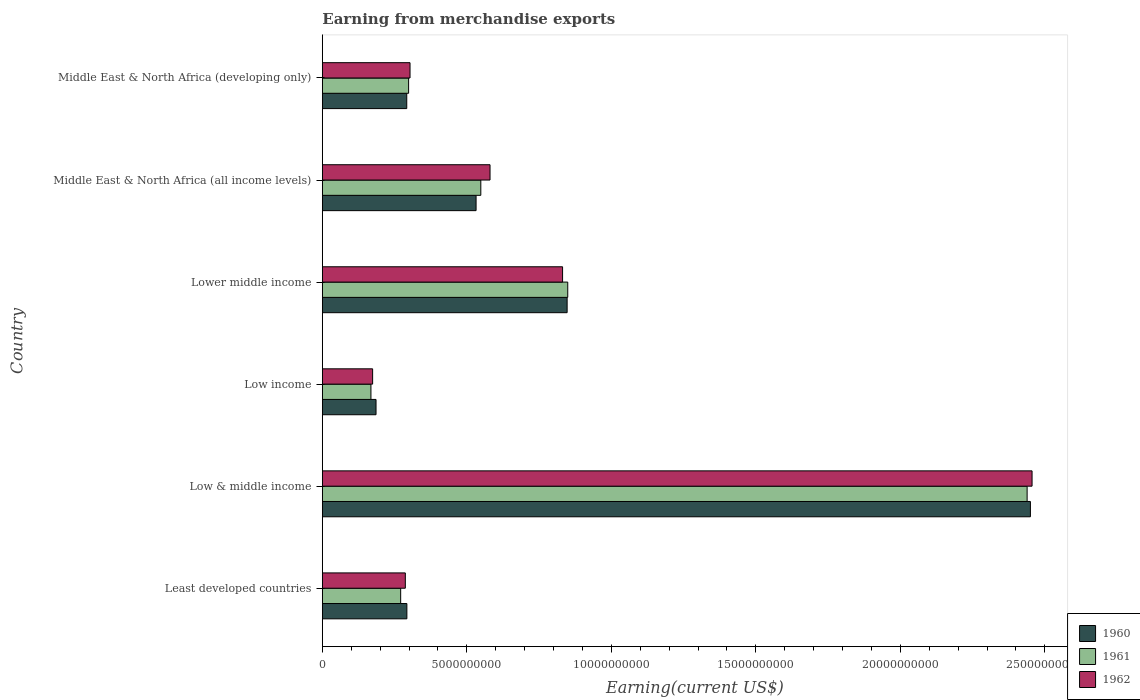How many different coloured bars are there?
Offer a terse response. 3. Are the number of bars on each tick of the Y-axis equal?
Offer a very short reply. Yes. How many bars are there on the 2nd tick from the top?
Offer a very short reply. 3. What is the label of the 2nd group of bars from the top?
Your answer should be very brief. Middle East & North Africa (all income levels). What is the amount earned from merchandise exports in 1962 in Lower middle income?
Offer a very short reply. 8.31e+09. Across all countries, what is the maximum amount earned from merchandise exports in 1961?
Your answer should be compact. 2.44e+1. Across all countries, what is the minimum amount earned from merchandise exports in 1960?
Keep it short and to the point. 1.86e+09. What is the total amount earned from merchandise exports in 1961 in the graph?
Offer a very short reply. 4.57e+1. What is the difference between the amount earned from merchandise exports in 1962 in Least developed countries and that in Middle East & North Africa (all income levels)?
Provide a succinct answer. -2.93e+09. What is the difference between the amount earned from merchandise exports in 1960 in Lower middle income and the amount earned from merchandise exports in 1962 in Middle East & North Africa (developing only)?
Keep it short and to the point. 5.44e+09. What is the average amount earned from merchandise exports in 1962 per country?
Your answer should be compact. 7.72e+09. What is the difference between the amount earned from merchandise exports in 1961 and amount earned from merchandise exports in 1962 in Low & middle income?
Offer a very short reply. -1.71e+08. What is the ratio of the amount earned from merchandise exports in 1960 in Low income to that in Middle East & North Africa (developing only)?
Provide a short and direct response. 0.64. What is the difference between the highest and the second highest amount earned from merchandise exports in 1961?
Provide a succinct answer. 1.59e+1. What is the difference between the highest and the lowest amount earned from merchandise exports in 1961?
Ensure brevity in your answer.  2.27e+1. Is the sum of the amount earned from merchandise exports in 1962 in Least developed countries and Middle East & North Africa (all income levels) greater than the maximum amount earned from merchandise exports in 1960 across all countries?
Keep it short and to the point. No. What does the 1st bar from the bottom in Lower middle income represents?
Your answer should be compact. 1960. How many bars are there?
Offer a terse response. 18. Are all the bars in the graph horizontal?
Give a very brief answer. Yes. How many countries are there in the graph?
Provide a succinct answer. 6. What is the difference between two consecutive major ticks on the X-axis?
Make the answer very short. 5.00e+09. Are the values on the major ticks of X-axis written in scientific E-notation?
Provide a short and direct response. No. Where does the legend appear in the graph?
Provide a short and direct response. Bottom right. How many legend labels are there?
Provide a short and direct response. 3. How are the legend labels stacked?
Your response must be concise. Vertical. What is the title of the graph?
Your response must be concise. Earning from merchandise exports. Does "1976" appear as one of the legend labels in the graph?
Keep it short and to the point. No. What is the label or title of the X-axis?
Your response must be concise. Earning(current US$). What is the Earning(current US$) in 1960 in Least developed countries?
Your answer should be very brief. 2.93e+09. What is the Earning(current US$) in 1961 in Least developed countries?
Your response must be concise. 2.71e+09. What is the Earning(current US$) in 1962 in Least developed countries?
Provide a short and direct response. 2.87e+09. What is the Earning(current US$) in 1960 in Low & middle income?
Provide a short and direct response. 2.45e+1. What is the Earning(current US$) of 1961 in Low & middle income?
Keep it short and to the point. 2.44e+1. What is the Earning(current US$) in 1962 in Low & middle income?
Give a very brief answer. 2.46e+1. What is the Earning(current US$) of 1960 in Low income?
Your answer should be very brief. 1.86e+09. What is the Earning(current US$) of 1961 in Low income?
Ensure brevity in your answer.  1.68e+09. What is the Earning(current US$) in 1962 in Low income?
Your response must be concise. 1.74e+09. What is the Earning(current US$) in 1960 in Lower middle income?
Your answer should be compact. 8.47e+09. What is the Earning(current US$) of 1961 in Lower middle income?
Keep it short and to the point. 8.49e+09. What is the Earning(current US$) of 1962 in Lower middle income?
Make the answer very short. 8.31e+09. What is the Earning(current US$) in 1960 in Middle East & North Africa (all income levels)?
Provide a short and direct response. 5.32e+09. What is the Earning(current US$) of 1961 in Middle East & North Africa (all income levels)?
Your response must be concise. 5.48e+09. What is the Earning(current US$) of 1962 in Middle East & North Africa (all income levels)?
Ensure brevity in your answer.  5.80e+09. What is the Earning(current US$) of 1960 in Middle East & North Africa (developing only)?
Keep it short and to the point. 2.92e+09. What is the Earning(current US$) of 1961 in Middle East & North Africa (developing only)?
Give a very brief answer. 2.99e+09. What is the Earning(current US$) of 1962 in Middle East & North Africa (developing only)?
Your answer should be very brief. 3.03e+09. Across all countries, what is the maximum Earning(current US$) in 1960?
Provide a short and direct response. 2.45e+1. Across all countries, what is the maximum Earning(current US$) of 1961?
Keep it short and to the point. 2.44e+1. Across all countries, what is the maximum Earning(current US$) of 1962?
Make the answer very short. 2.46e+1. Across all countries, what is the minimum Earning(current US$) of 1960?
Your answer should be compact. 1.86e+09. Across all countries, what is the minimum Earning(current US$) in 1961?
Make the answer very short. 1.68e+09. Across all countries, what is the minimum Earning(current US$) in 1962?
Provide a short and direct response. 1.74e+09. What is the total Earning(current US$) of 1960 in the graph?
Your response must be concise. 4.60e+1. What is the total Earning(current US$) in 1961 in the graph?
Ensure brevity in your answer.  4.57e+1. What is the total Earning(current US$) of 1962 in the graph?
Provide a short and direct response. 4.63e+1. What is the difference between the Earning(current US$) of 1960 in Least developed countries and that in Low & middle income?
Your answer should be very brief. -2.16e+1. What is the difference between the Earning(current US$) of 1961 in Least developed countries and that in Low & middle income?
Make the answer very short. -2.17e+1. What is the difference between the Earning(current US$) in 1962 in Least developed countries and that in Low & middle income?
Keep it short and to the point. -2.17e+1. What is the difference between the Earning(current US$) in 1960 in Least developed countries and that in Low income?
Give a very brief answer. 1.07e+09. What is the difference between the Earning(current US$) in 1961 in Least developed countries and that in Low income?
Make the answer very short. 1.03e+09. What is the difference between the Earning(current US$) in 1962 in Least developed countries and that in Low income?
Provide a short and direct response. 1.13e+09. What is the difference between the Earning(current US$) of 1960 in Least developed countries and that in Lower middle income?
Ensure brevity in your answer.  -5.54e+09. What is the difference between the Earning(current US$) in 1961 in Least developed countries and that in Lower middle income?
Offer a very short reply. -5.78e+09. What is the difference between the Earning(current US$) of 1962 in Least developed countries and that in Lower middle income?
Ensure brevity in your answer.  -5.44e+09. What is the difference between the Earning(current US$) of 1960 in Least developed countries and that in Middle East & North Africa (all income levels)?
Give a very brief answer. -2.39e+09. What is the difference between the Earning(current US$) of 1961 in Least developed countries and that in Middle East & North Africa (all income levels)?
Your response must be concise. -2.77e+09. What is the difference between the Earning(current US$) in 1962 in Least developed countries and that in Middle East & North Africa (all income levels)?
Make the answer very short. -2.93e+09. What is the difference between the Earning(current US$) in 1960 in Least developed countries and that in Middle East & North Africa (developing only)?
Offer a terse response. 4.02e+06. What is the difference between the Earning(current US$) in 1961 in Least developed countries and that in Middle East & North Africa (developing only)?
Make the answer very short. -2.75e+08. What is the difference between the Earning(current US$) of 1962 in Least developed countries and that in Middle East & North Africa (developing only)?
Ensure brevity in your answer.  -1.63e+08. What is the difference between the Earning(current US$) of 1960 in Low & middle income and that in Low income?
Make the answer very short. 2.26e+1. What is the difference between the Earning(current US$) in 1961 in Low & middle income and that in Low income?
Provide a short and direct response. 2.27e+1. What is the difference between the Earning(current US$) in 1962 in Low & middle income and that in Low income?
Provide a succinct answer. 2.28e+1. What is the difference between the Earning(current US$) of 1960 in Low & middle income and that in Lower middle income?
Ensure brevity in your answer.  1.60e+1. What is the difference between the Earning(current US$) in 1961 in Low & middle income and that in Lower middle income?
Give a very brief answer. 1.59e+1. What is the difference between the Earning(current US$) of 1962 in Low & middle income and that in Lower middle income?
Keep it short and to the point. 1.62e+1. What is the difference between the Earning(current US$) of 1960 in Low & middle income and that in Middle East & North Africa (all income levels)?
Your answer should be very brief. 1.92e+1. What is the difference between the Earning(current US$) in 1961 in Low & middle income and that in Middle East & North Africa (all income levels)?
Ensure brevity in your answer.  1.89e+1. What is the difference between the Earning(current US$) of 1962 in Low & middle income and that in Middle East & North Africa (all income levels)?
Offer a very short reply. 1.88e+1. What is the difference between the Earning(current US$) of 1960 in Low & middle income and that in Middle East & North Africa (developing only)?
Offer a very short reply. 2.16e+1. What is the difference between the Earning(current US$) of 1961 in Low & middle income and that in Middle East & North Africa (developing only)?
Ensure brevity in your answer.  2.14e+1. What is the difference between the Earning(current US$) of 1962 in Low & middle income and that in Middle East & North Africa (developing only)?
Make the answer very short. 2.15e+1. What is the difference between the Earning(current US$) of 1960 in Low income and that in Lower middle income?
Provide a short and direct response. -6.61e+09. What is the difference between the Earning(current US$) in 1961 in Low income and that in Lower middle income?
Ensure brevity in your answer.  -6.81e+09. What is the difference between the Earning(current US$) in 1962 in Low income and that in Lower middle income?
Offer a very short reply. -6.57e+09. What is the difference between the Earning(current US$) of 1960 in Low income and that in Middle East & North Africa (all income levels)?
Make the answer very short. -3.46e+09. What is the difference between the Earning(current US$) in 1961 in Low income and that in Middle East & North Africa (all income levels)?
Keep it short and to the point. -3.80e+09. What is the difference between the Earning(current US$) of 1962 in Low income and that in Middle East & North Africa (all income levels)?
Make the answer very short. -4.06e+09. What is the difference between the Earning(current US$) in 1960 in Low income and that in Middle East & North Africa (developing only)?
Your response must be concise. -1.06e+09. What is the difference between the Earning(current US$) in 1961 in Low income and that in Middle East & North Africa (developing only)?
Give a very brief answer. -1.30e+09. What is the difference between the Earning(current US$) in 1962 in Low income and that in Middle East & North Africa (developing only)?
Your answer should be compact. -1.29e+09. What is the difference between the Earning(current US$) in 1960 in Lower middle income and that in Middle East & North Africa (all income levels)?
Make the answer very short. 3.15e+09. What is the difference between the Earning(current US$) in 1961 in Lower middle income and that in Middle East & North Africa (all income levels)?
Provide a succinct answer. 3.01e+09. What is the difference between the Earning(current US$) of 1962 in Lower middle income and that in Middle East & North Africa (all income levels)?
Offer a terse response. 2.51e+09. What is the difference between the Earning(current US$) in 1960 in Lower middle income and that in Middle East & North Africa (developing only)?
Offer a terse response. 5.55e+09. What is the difference between the Earning(current US$) of 1961 in Lower middle income and that in Middle East & North Africa (developing only)?
Your answer should be very brief. 5.51e+09. What is the difference between the Earning(current US$) of 1962 in Lower middle income and that in Middle East & North Africa (developing only)?
Your response must be concise. 5.28e+09. What is the difference between the Earning(current US$) in 1960 in Middle East & North Africa (all income levels) and that in Middle East & North Africa (developing only)?
Offer a very short reply. 2.40e+09. What is the difference between the Earning(current US$) of 1961 in Middle East & North Africa (all income levels) and that in Middle East & North Africa (developing only)?
Provide a succinct answer. 2.50e+09. What is the difference between the Earning(current US$) in 1962 in Middle East & North Africa (all income levels) and that in Middle East & North Africa (developing only)?
Give a very brief answer. 2.77e+09. What is the difference between the Earning(current US$) in 1960 in Least developed countries and the Earning(current US$) in 1961 in Low & middle income?
Provide a short and direct response. -2.15e+1. What is the difference between the Earning(current US$) of 1960 in Least developed countries and the Earning(current US$) of 1962 in Low & middle income?
Your answer should be compact. -2.16e+1. What is the difference between the Earning(current US$) of 1961 in Least developed countries and the Earning(current US$) of 1962 in Low & middle income?
Make the answer very short. -2.18e+1. What is the difference between the Earning(current US$) in 1960 in Least developed countries and the Earning(current US$) in 1961 in Low income?
Your answer should be compact. 1.24e+09. What is the difference between the Earning(current US$) in 1960 in Least developed countries and the Earning(current US$) in 1962 in Low income?
Ensure brevity in your answer.  1.18e+09. What is the difference between the Earning(current US$) of 1961 in Least developed countries and the Earning(current US$) of 1962 in Low income?
Give a very brief answer. 9.70e+08. What is the difference between the Earning(current US$) of 1960 in Least developed countries and the Earning(current US$) of 1961 in Lower middle income?
Your answer should be compact. -5.57e+09. What is the difference between the Earning(current US$) of 1960 in Least developed countries and the Earning(current US$) of 1962 in Lower middle income?
Your answer should be compact. -5.39e+09. What is the difference between the Earning(current US$) of 1961 in Least developed countries and the Earning(current US$) of 1962 in Lower middle income?
Keep it short and to the point. -5.60e+09. What is the difference between the Earning(current US$) of 1960 in Least developed countries and the Earning(current US$) of 1961 in Middle East & North Africa (all income levels)?
Provide a short and direct response. -2.56e+09. What is the difference between the Earning(current US$) in 1960 in Least developed countries and the Earning(current US$) in 1962 in Middle East & North Africa (all income levels)?
Offer a very short reply. -2.88e+09. What is the difference between the Earning(current US$) in 1961 in Least developed countries and the Earning(current US$) in 1962 in Middle East & North Africa (all income levels)?
Keep it short and to the point. -3.09e+09. What is the difference between the Earning(current US$) of 1960 in Least developed countries and the Earning(current US$) of 1961 in Middle East & North Africa (developing only)?
Offer a terse response. -6.04e+07. What is the difference between the Earning(current US$) of 1960 in Least developed countries and the Earning(current US$) of 1962 in Middle East & North Africa (developing only)?
Provide a short and direct response. -1.09e+08. What is the difference between the Earning(current US$) in 1961 in Least developed countries and the Earning(current US$) in 1962 in Middle East & North Africa (developing only)?
Provide a succinct answer. -3.24e+08. What is the difference between the Earning(current US$) in 1960 in Low & middle income and the Earning(current US$) in 1961 in Low income?
Keep it short and to the point. 2.28e+1. What is the difference between the Earning(current US$) in 1960 in Low & middle income and the Earning(current US$) in 1962 in Low income?
Provide a short and direct response. 2.28e+1. What is the difference between the Earning(current US$) of 1961 in Low & middle income and the Earning(current US$) of 1962 in Low income?
Offer a very short reply. 2.26e+1. What is the difference between the Earning(current US$) in 1960 in Low & middle income and the Earning(current US$) in 1961 in Lower middle income?
Offer a very short reply. 1.60e+1. What is the difference between the Earning(current US$) in 1960 in Low & middle income and the Earning(current US$) in 1962 in Lower middle income?
Your answer should be very brief. 1.62e+1. What is the difference between the Earning(current US$) of 1961 in Low & middle income and the Earning(current US$) of 1962 in Lower middle income?
Your response must be concise. 1.61e+1. What is the difference between the Earning(current US$) of 1960 in Low & middle income and the Earning(current US$) of 1961 in Middle East & North Africa (all income levels)?
Ensure brevity in your answer.  1.90e+1. What is the difference between the Earning(current US$) of 1960 in Low & middle income and the Earning(current US$) of 1962 in Middle East & North Africa (all income levels)?
Your answer should be compact. 1.87e+1. What is the difference between the Earning(current US$) in 1961 in Low & middle income and the Earning(current US$) in 1962 in Middle East & North Africa (all income levels)?
Provide a short and direct response. 1.86e+1. What is the difference between the Earning(current US$) of 1960 in Low & middle income and the Earning(current US$) of 1961 in Middle East & North Africa (developing only)?
Offer a very short reply. 2.15e+1. What is the difference between the Earning(current US$) in 1960 in Low & middle income and the Earning(current US$) in 1962 in Middle East & North Africa (developing only)?
Provide a short and direct response. 2.15e+1. What is the difference between the Earning(current US$) in 1961 in Low & middle income and the Earning(current US$) in 1962 in Middle East & North Africa (developing only)?
Make the answer very short. 2.14e+1. What is the difference between the Earning(current US$) in 1960 in Low income and the Earning(current US$) in 1961 in Lower middle income?
Ensure brevity in your answer.  -6.63e+09. What is the difference between the Earning(current US$) of 1960 in Low income and the Earning(current US$) of 1962 in Lower middle income?
Offer a very short reply. -6.45e+09. What is the difference between the Earning(current US$) of 1961 in Low income and the Earning(current US$) of 1962 in Lower middle income?
Your response must be concise. -6.63e+09. What is the difference between the Earning(current US$) of 1960 in Low income and the Earning(current US$) of 1961 in Middle East & North Africa (all income levels)?
Your answer should be very brief. -3.63e+09. What is the difference between the Earning(current US$) of 1960 in Low income and the Earning(current US$) of 1962 in Middle East & North Africa (all income levels)?
Offer a terse response. -3.94e+09. What is the difference between the Earning(current US$) in 1961 in Low income and the Earning(current US$) in 1962 in Middle East & North Africa (all income levels)?
Provide a short and direct response. -4.12e+09. What is the difference between the Earning(current US$) in 1960 in Low income and the Earning(current US$) in 1961 in Middle East & North Africa (developing only)?
Your answer should be compact. -1.13e+09. What is the difference between the Earning(current US$) in 1960 in Low income and the Earning(current US$) in 1962 in Middle East & North Africa (developing only)?
Offer a very short reply. -1.18e+09. What is the difference between the Earning(current US$) of 1961 in Low income and the Earning(current US$) of 1962 in Middle East & North Africa (developing only)?
Make the answer very short. -1.35e+09. What is the difference between the Earning(current US$) in 1960 in Lower middle income and the Earning(current US$) in 1961 in Middle East & North Africa (all income levels)?
Provide a succinct answer. 2.99e+09. What is the difference between the Earning(current US$) in 1960 in Lower middle income and the Earning(current US$) in 1962 in Middle East & North Africa (all income levels)?
Provide a short and direct response. 2.67e+09. What is the difference between the Earning(current US$) in 1961 in Lower middle income and the Earning(current US$) in 1962 in Middle East & North Africa (all income levels)?
Your answer should be compact. 2.69e+09. What is the difference between the Earning(current US$) of 1960 in Lower middle income and the Earning(current US$) of 1961 in Middle East & North Africa (developing only)?
Make the answer very short. 5.48e+09. What is the difference between the Earning(current US$) of 1960 in Lower middle income and the Earning(current US$) of 1962 in Middle East & North Africa (developing only)?
Your answer should be compact. 5.44e+09. What is the difference between the Earning(current US$) in 1961 in Lower middle income and the Earning(current US$) in 1962 in Middle East & North Africa (developing only)?
Your answer should be compact. 5.46e+09. What is the difference between the Earning(current US$) of 1960 in Middle East & North Africa (all income levels) and the Earning(current US$) of 1961 in Middle East & North Africa (developing only)?
Ensure brevity in your answer.  2.33e+09. What is the difference between the Earning(current US$) in 1960 in Middle East & North Africa (all income levels) and the Earning(current US$) in 1962 in Middle East & North Africa (developing only)?
Your answer should be very brief. 2.29e+09. What is the difference between the Earning(current US$) in 1961 in Middle East & North Africa (all income levels) and the Earning(current US$) in 1962 in Middle East & North Africa (developing only)?
Ensure brevity in your answer.  2.45e+09. What is the average Earning(current US$) in 1960 per country?
Your answer should be compact. 7.67e+09. What is the average Earning(current US$) in 1961 per country?
Offer a very short reply. 7.62e+09. What is the average Earning(current US$) in 1962 per country?
Your answer should be compact. 7.72e+09. What is the difference between the Earning(current US$) of 1960 and Earning(current US$) of 1961 in Least developed countries?
Your answer should be very brief. 2.14e+08. What is the difference between the Earning(current US$) in 1960 and Earning(current US$) in 1962 in Least developed countries?
Keep it short and to the point. 5.34e+07. What is the difference between the Earning(current US$) of 1961 and Earning(current US$) of 1962 in Least developed countries?
Offer a terse response. -1.61e+08. What is the difference between the Earning(current US$) in 1960 and Earning(current US$) in 1961 in Low & middle income?
Provide a short and direct response. 1.14e+08. What is the difference between the Earning(current US$) of 1960 and Earning(current US$) of 1962 in Low & middle income?
Make the answer very short. -5.72e+07. What is the difference between the Earning(current US$) in 1961 and Earning(current US$) in 1962 in Low & middle income?
Give a very brief answer. -1.71e+08. What is the difference between the Earning(current US$) in 1960 and Earning(current US$) in 1961 in Low income?
Provide a succinct answer. 1.76e+08. What is the difference between the Earning(current US$) in 1960 and Earning(current US$) in 1962 in Low income?
Offer a very short reply. 1.18e+08. What is the difference between the Earning(current US$) in 1961 and Earning(current US$) in 1962 in Low income?
Ensure brevity in your answer.  -5.83e+07. What is the difference between the Earning(current US$) of 1960 and Earning(current US$) of 1961 in Lower middle income?
Provide a short and direct response. -2.17e+07. What is the difference between the Earning(current US$) in 1960 and Earning(current US$) in 1962 in Lower middle income?
Ensure brevity in your answer.  1.57e+08. What is the difference between the Earning(current US$) of 1961 and Earning(current US$) of 1962 in Lower middle income?
Offer a very short reply. 1.79e+08. What is the difference between the Earning(current US$) of 1960 and Earning(current US$) of 1961 in Middle East & North Africa (all income levels)?
Make the answer very short. -1.64e+08. What is the difference between the Earning(current US$) in 1960 and Earning(current US$) in 1962 in Middle East & North Africa (all income levels)?
Your answer should be compact. -4.83e+08. What is the difference between the Earning(current US$) of 1961 and Earning(current US$) of 1962 in Middle East & North Africa (all income levels)?
Give a very brief answer. -3.19e+08. What is the difference between the Earning(current US$) in 1960 and Earning(current US$) in 1961 in Middle East & North Africa (developing only)?
Provide a short and direct response. -6.44e+07. What is the difference between the Earning(current US$) in 1960 and Earning(current US$) in 1962 in Middle East & North Africa (developing only)?
Offer a very short reply. -1.13e+08. What is the difference between the Earning(current US$) of 1961 and Earning(current US$) of 1962 in Middle East & North Africa (developing only)?
Provide a succinct answer. -4.89e+07. What is the ratio of the Earning(current US$) of 1960 in Least developed countries to that in Low & middle income?
Offer a terse response. 0.12. What is the ratio of the Earning(current US$) of 1961 in Least developed countries to that in Low & middle income?
Make the answer very short. 0.11. What is the ratio of the Earning(current US$) of 1962 in Least developed countries to that in Low & middle income?
Provide a short and direct response. 0.12. What is the ratio of the Earning(current US$) in 1960 in Least developed countries to that in Low income?
Keep it short and to the point. 1.57. What is the ratio of the Earning(current US$) in 1961 in Least developed countries to that in Low income?
Offer a terse response. 1.61. What is the ratio of the Earning(current US$) of 1962 in Least developed countries to that in Low income?
Ensure brevity in your answer.  1.65. What is the ratio of the Earning(current US$) of 1960 in Least developed countries to that in Lower middle income?
Your answer should be very brief. 0.35. What is the ratio of the Earning(current US$) in 1961 in Least developed countries to that in Lower middle income?
Keep it short and to the point. 0.32. What is the ratio of the Earning(current US$) in 1962 in Least developed countries to that in Lower middle income?
Offer a terse response. 0.35. What is the ratio of the Earning(current US$) of 1960 in Least developed countries to that in Middle East & North Africa (all income levels)?
Give a very brief answer. 0.55. What is the ratio of the Earning(current US$) in 1961 in Least developed countries to that in Middle East & North Africa (all income levels)?
Give a very brief answer. 0.49. What is the ratio of the Earning(current US$) of 1962 in Least developed countries to that in Middle East & North Africa (all income levels)?
Give a very brief answer. 0.49. What is the ratio of the Earning(current US$) in 1961 in Least developed countries to that in Middle East & North Africa (developing only)?
Offer a very short reply. 0.91. What is the ratio of the Earning(current US$) in 1962 in Least developed countries to that in Middle East & North Africa (developing only)?
Give a very brief answer. 0.95. What is the ratio of the Earning(current US$) in 1960 in Low & middle income to that in Low income?
Your response must be concise. 13.19. What is the ratio of the Earning(current US$) in 1961 in Low & middle income to that in Low income?
Your response must be concise. 14.5. What is the ratio of the Earning(current US$) in 1962 in Low & middle income to that in Low income?
Make the answer very short. 14.11. What is the ratio of the Earning(current US$) in 1960 in Low & middle income to that in Lower middle income?
Provide a succinct answer. 2.89. What is the ratio of the Earning(current US$) in 1961 in Low & middle income to that in Lower middle income?
Your answer should be very brief. 2.87. What is the ratio of the Earning(current US$) of 1962 in Low & middle income to that in Lower middle income?
Offer a terse response. 2.95. What is the ratio of the Earning(current US$) of 1960 in Low & middle income to that in Middle East & North Africa (all income levels)?
Give a very brief answer. 4.61. What is the ratio of the Earning(current US$) of 1961 in Low & middle income to that in Middle East & North Africa (all income levels)?
Provide a succinct answer. 4.45. What is the ratio of the Earning(current US$) of 1962 in Low & middle income to that in Middle East & North Africa (all income levels)?
Provide a succinct answer. 4.23. What is the ratio of the Earning(current US$) in 1960 in Low & middle income to that in Middle East & North Africa (developing only)?
Make the answer very short. 8.39. What is the ratio of the Earning(current US$) of 1961 in Low & middle income to that in Middle East & North Africa (developing only)?
Provide a short and direct response. 8.17. What is the ratio of the Earning(current US$) of 1962 in Low & middle income to that in Middle East & North Africa (developing only)?
Provide a succinct answer. 8.09. What is the ratio of the Earning(current US$) in 1960 in Low income to that in Lower middle income?
Your answer should be very brief. 0.22. What is the ratio of the Earning(current US$) of 1961 in Low income to that in Lower middle income?
Ensure brevity in your answer.  0.2. What is the ratio of the Earning(current US$) of 1962 in Low income to that in Lower middle income?
Offer a terse response. 0.21. What is the ratio of the Earning(current US$) in 1960 in Low income to that in Middle East & North Africa (all income levels)?
Provide a short and direct response. 0.35. What is the ratio of the Earning(current US$) of 1961 in Low income to that in Middle East & North Africa (all income levels)?
Provide a short and direct response. 0.31. What is the ratio of the Earning(current US$) in 1962 in Low income to that in Middle East & North Africa (all income levels)?
Your answer should be compact. 0.3. What is the ratio of the Earning(current US$) of 1960 in Low income to that in Middle East & North Africa (developing only)?
Your response must be concise. 0.64. What is the ratio of the Earning(current US$) in 1961 in Low income to that in Middle East & North Africa (developing only)?
Offer a terse response. 0.56. What is the ratio of the Earning(current US$) of 1962 in Low income to that in Middle East & North Africa (developing only)?
Ensure brevity in your answer.  0.57. What is the ratio of the Earning(current US$) in 1960 in Lower middle income to that in Middle East & North Africa (all income levels)?
Make the answer very short. 1.59. What is the ratio of the Earning(current US$) of 1961 in Lower middle income to that in Middle East & North Africa (all income levels)?
Keep it short and to the point. 1.55. What is the ratio of the Earning(current US$) of 1962 in Lower middle income to that in Middle East & North Africa (all income levels)?
Your answer should be compact. 1.43. What is the ratio of the Earning(current US$) in 1960 in Lower middle income to that in Middle East & North Africa (developing only)?
Keep it short and to the point. 2.9. What is the ratio of the Earning(current US$) of 1961 in Lower middle income to that in Middle East & North Africa (developing only)?
Your response must be concise. 2.84. What is the ratio of the Earning(current US$) of 1962 in Lower middle income to that in Middle East & North Africa (developing only)?
Ensure brevity in your answer.  2.74. What is the ratio of the Earning(current US$) of 1960 in Middle East & North Africa (all income levels) to that in Middle East & North Africa (developing only)?
Your answer should be compact. 1.82. What is the ratio of the Earning(current US$) in 1961 in Middle East & North Africa (all income levels) to that in Middle East & North Africa (developing only)?
Offer a terse response. 1.84. What is the ratio of the Earning(current US$) of 1962 in Middle East & North Africa (all income levels) to that in Middle East & North Africa (developing only)?
Give a very brief answer. 1.91. What is the difference between the highest and the second highest Earning(current US$) of 1960?
Keep it short and to the point. 1.60e+1. What is the difference between the highest and the second highest Earning(current US$) in 1961?
Offer a terse response. 1.59e+1. What is the difference between the highest and the second highest Earning(current US$) of 1962?
Provide a short and direct response. 1.62e+1. What is the difference between the highest and the lowest Earning(current US$) in 1960?
Give a very brief answer. 2.26e+1. What is the difference between the highest and the lowest Earning(current US$) in 1961?
Offer a terse response. 2.27e+1. What is the difference between the highest and the lowest Earning(current US$) of 1962?
Ensure brevity in your answer.  2.28e+1. 